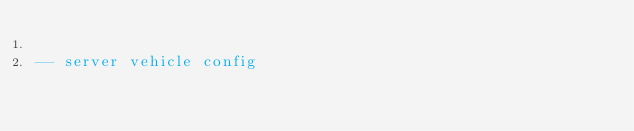Convert code to text. <code><loc_0><loc_0><loc_500><loc_500><_Lua_>
-- server vehicle config</code> 